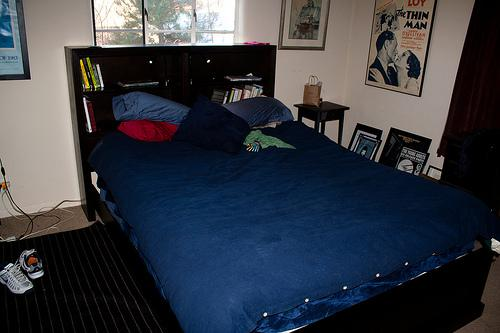Question: what color is the blanket?
Choices:
A. Yellow.
B. Blue.
C. White.
D. Black.
Answer with the letter. Answer: B Question: why is the window open?
Choices:
A. To let the breeze in the house.
B. To let light in.
C. Because someone is crawling through it.
D. Someone forgot to shut it.
Answer with the letter. Answer: B Question: where was the picture taken?
Choices:
A. On a plane.
B. Bedroom.
C. At the wedding.
D. At the hospital.
Answer with the letter. Answer: B 